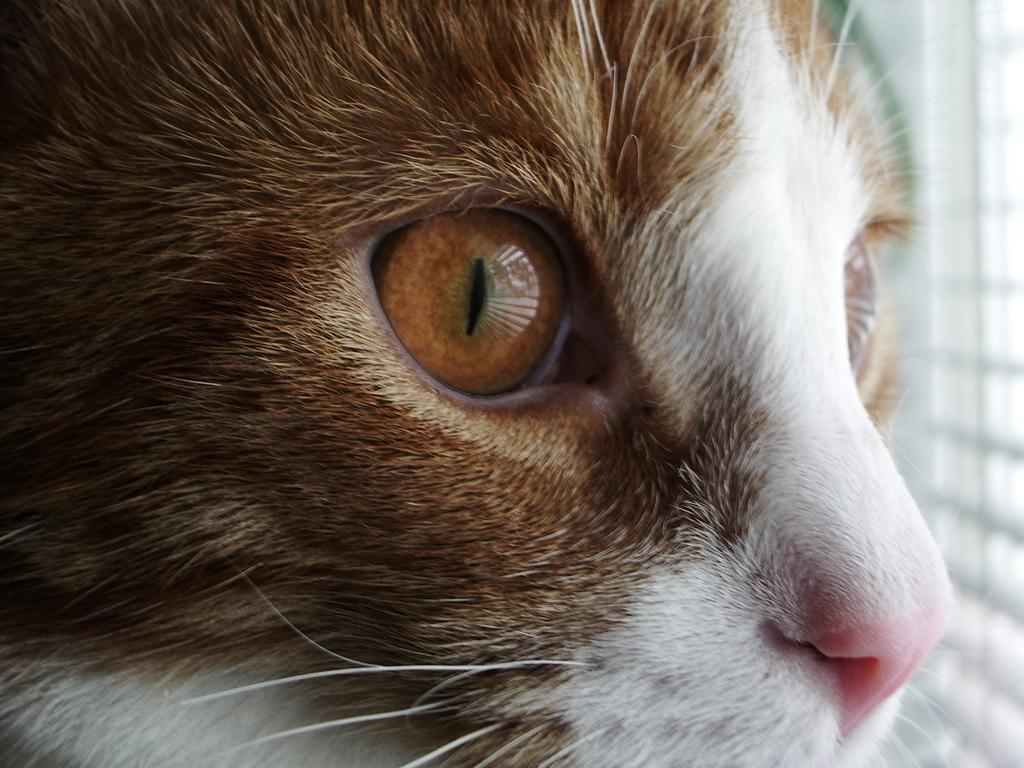What type of animal is in the image? There is a cat in the image. Can you describe the background of the image? The background of the image is blurred. What type of horn can be seen on the cat in the image? There is no horn present on the cat in the image. 